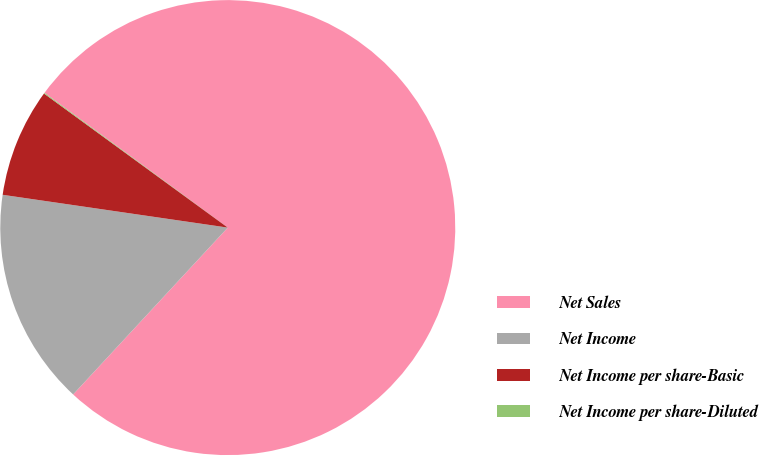<chart> <loc_0><loc_0><loc_500><loc_500><pie_chart><fcel>Net Sales<fcel>Net Income<fcel>Net Income per share-Basic<fcel>Net Income per share-Diluted<nl><fcel>76.81%<fcel>15.41%<fcel>7.73%<fcel>0.06%<nl></chart> 